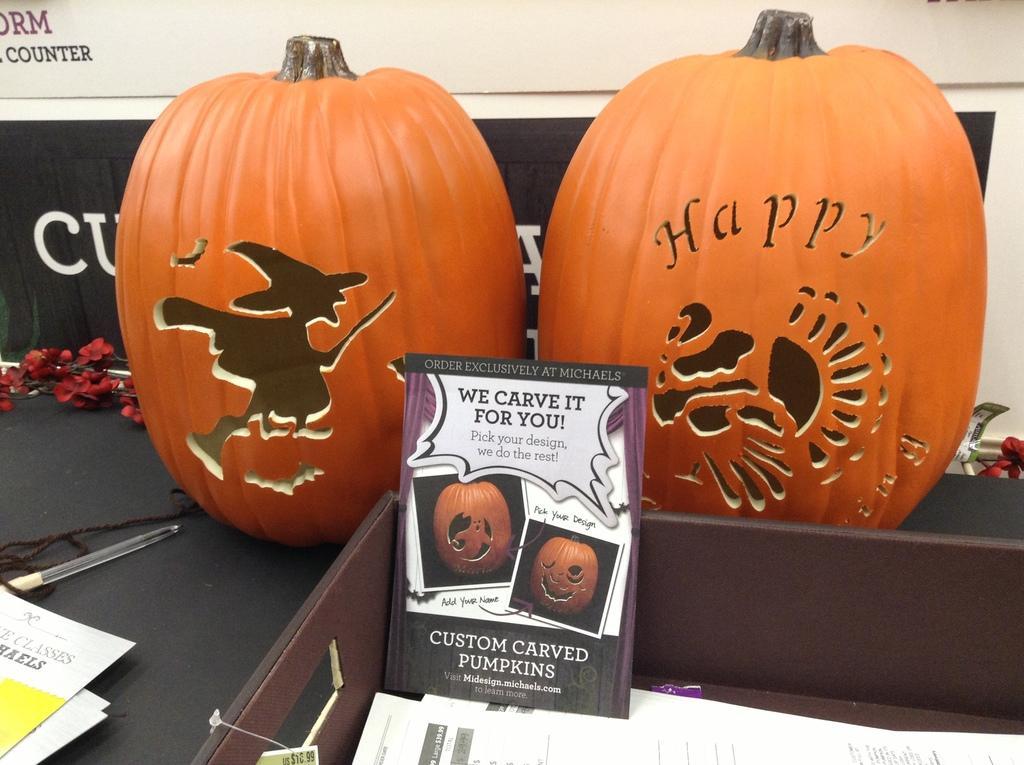How would you summarize this image in a sentence or two? This image consists of pumpkins. In the front, we can see a card. On the left, there are papers. It looks like the pumpkins are carved. In the background, there is a wall along with the text. Beside the pumpkin we can see a pen. 